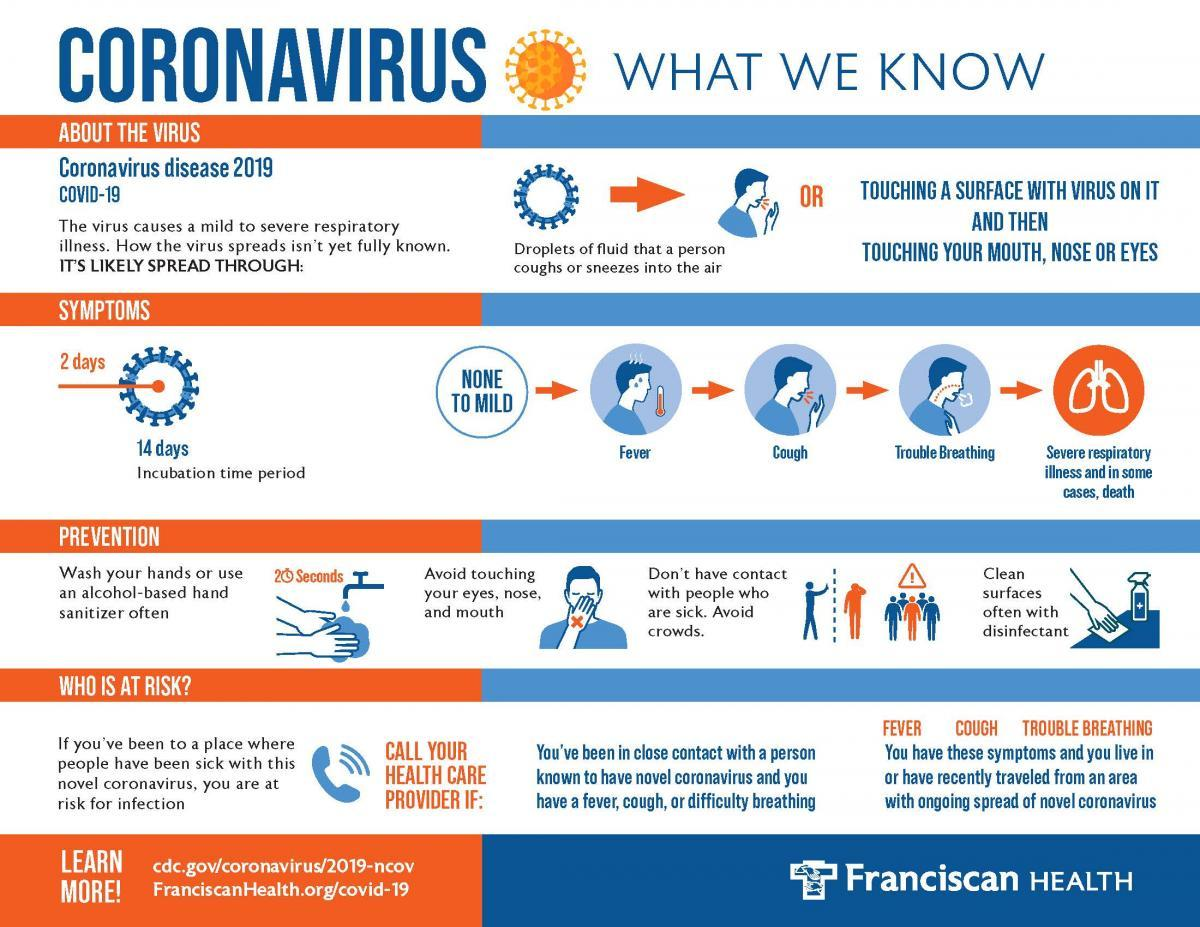Specify some key components in this picture. It is recommended to use alcohol-based hand sanitizer as a sanitizing agent for hand hygiene. Disinfectant can be used to clean and disinfect surfaces. The first three symptoms are fever, cough, and difficulty breathing. If you are at risk of infection, it is crucial that you immediately contact your health care provider for guidance and appropriate medical attention. For a duration of 20 seconds, it is recommended to wash your hands in order to effectively remove dirt and bacteria. 